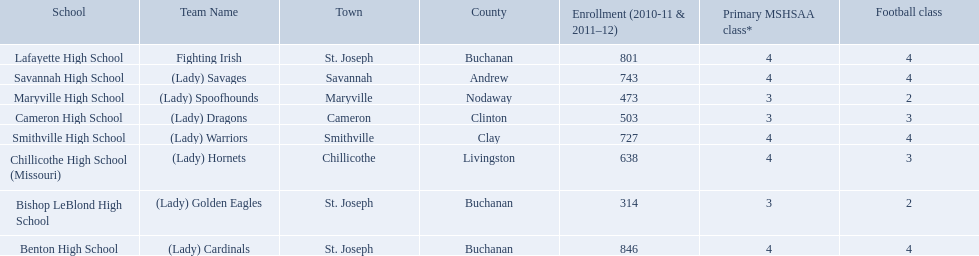What team uses green and grey as colors? Fighting Irish. What is this team called? Lafayette High School. 